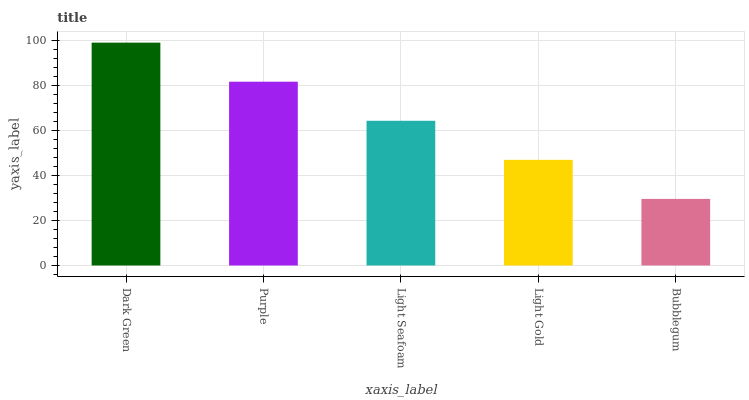Is Bubblegum the minimum?
Answer yes or no. Yes. Is Dark Green the maximum?
Answer yes or no. Yes. Is Purple the minimum?
Answer yes or no. No. Is Purple the maximum?
Answer yes or no. No. Is Dark Green greater than Purple?
Answer yes or no. Yes. Is Purple less than Dark Green?
Answer yes or no. Yes. Is Purple greater than Dark Green?
Answer yes or no. No. Is Dark Green less than Purple?
Answer yes or no. No. Is Light Seafoam the high median?
Answer yes or no. Yes. Is Light Seafoam the low median?
Answer yes or no. Yes. Is Dark Green the high median?
Answer yes or no. No. Is Purple the low median?
Answer yes or no. No. 